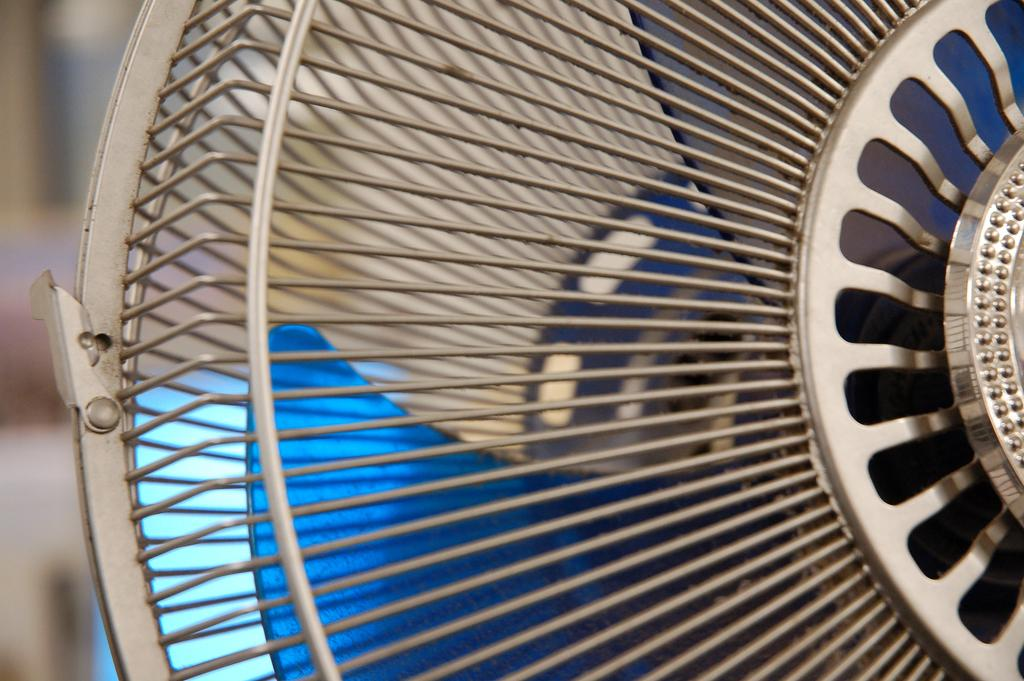What is the main object in the image? There is a table fan in the image. Can you describe the background of the image? The background of the image is blurred. How many pears are on the table next to the table fan in the image? There are no pears present in the image. Are the sisters in the image sitting at the table with the table fan? There is no mention of sisters or a table in the image, so we cannot answer this question. 